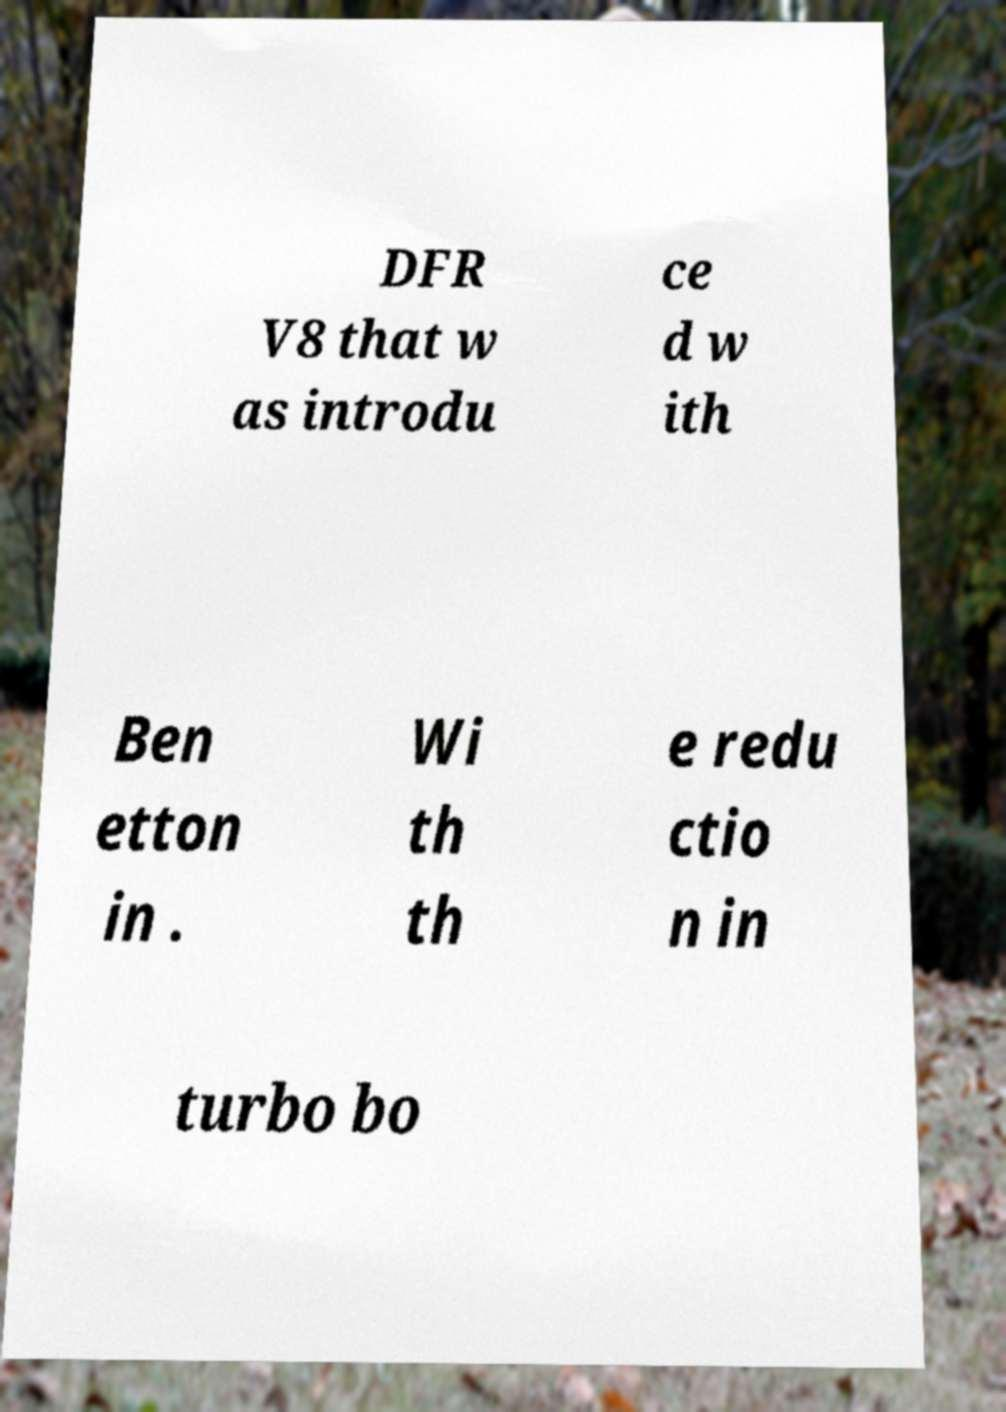Could you extract and type out the text from this image? DFR V8 that w as introdu ce d w ith Ben etton in . Wi th th e redu ctio n in turbo bo 